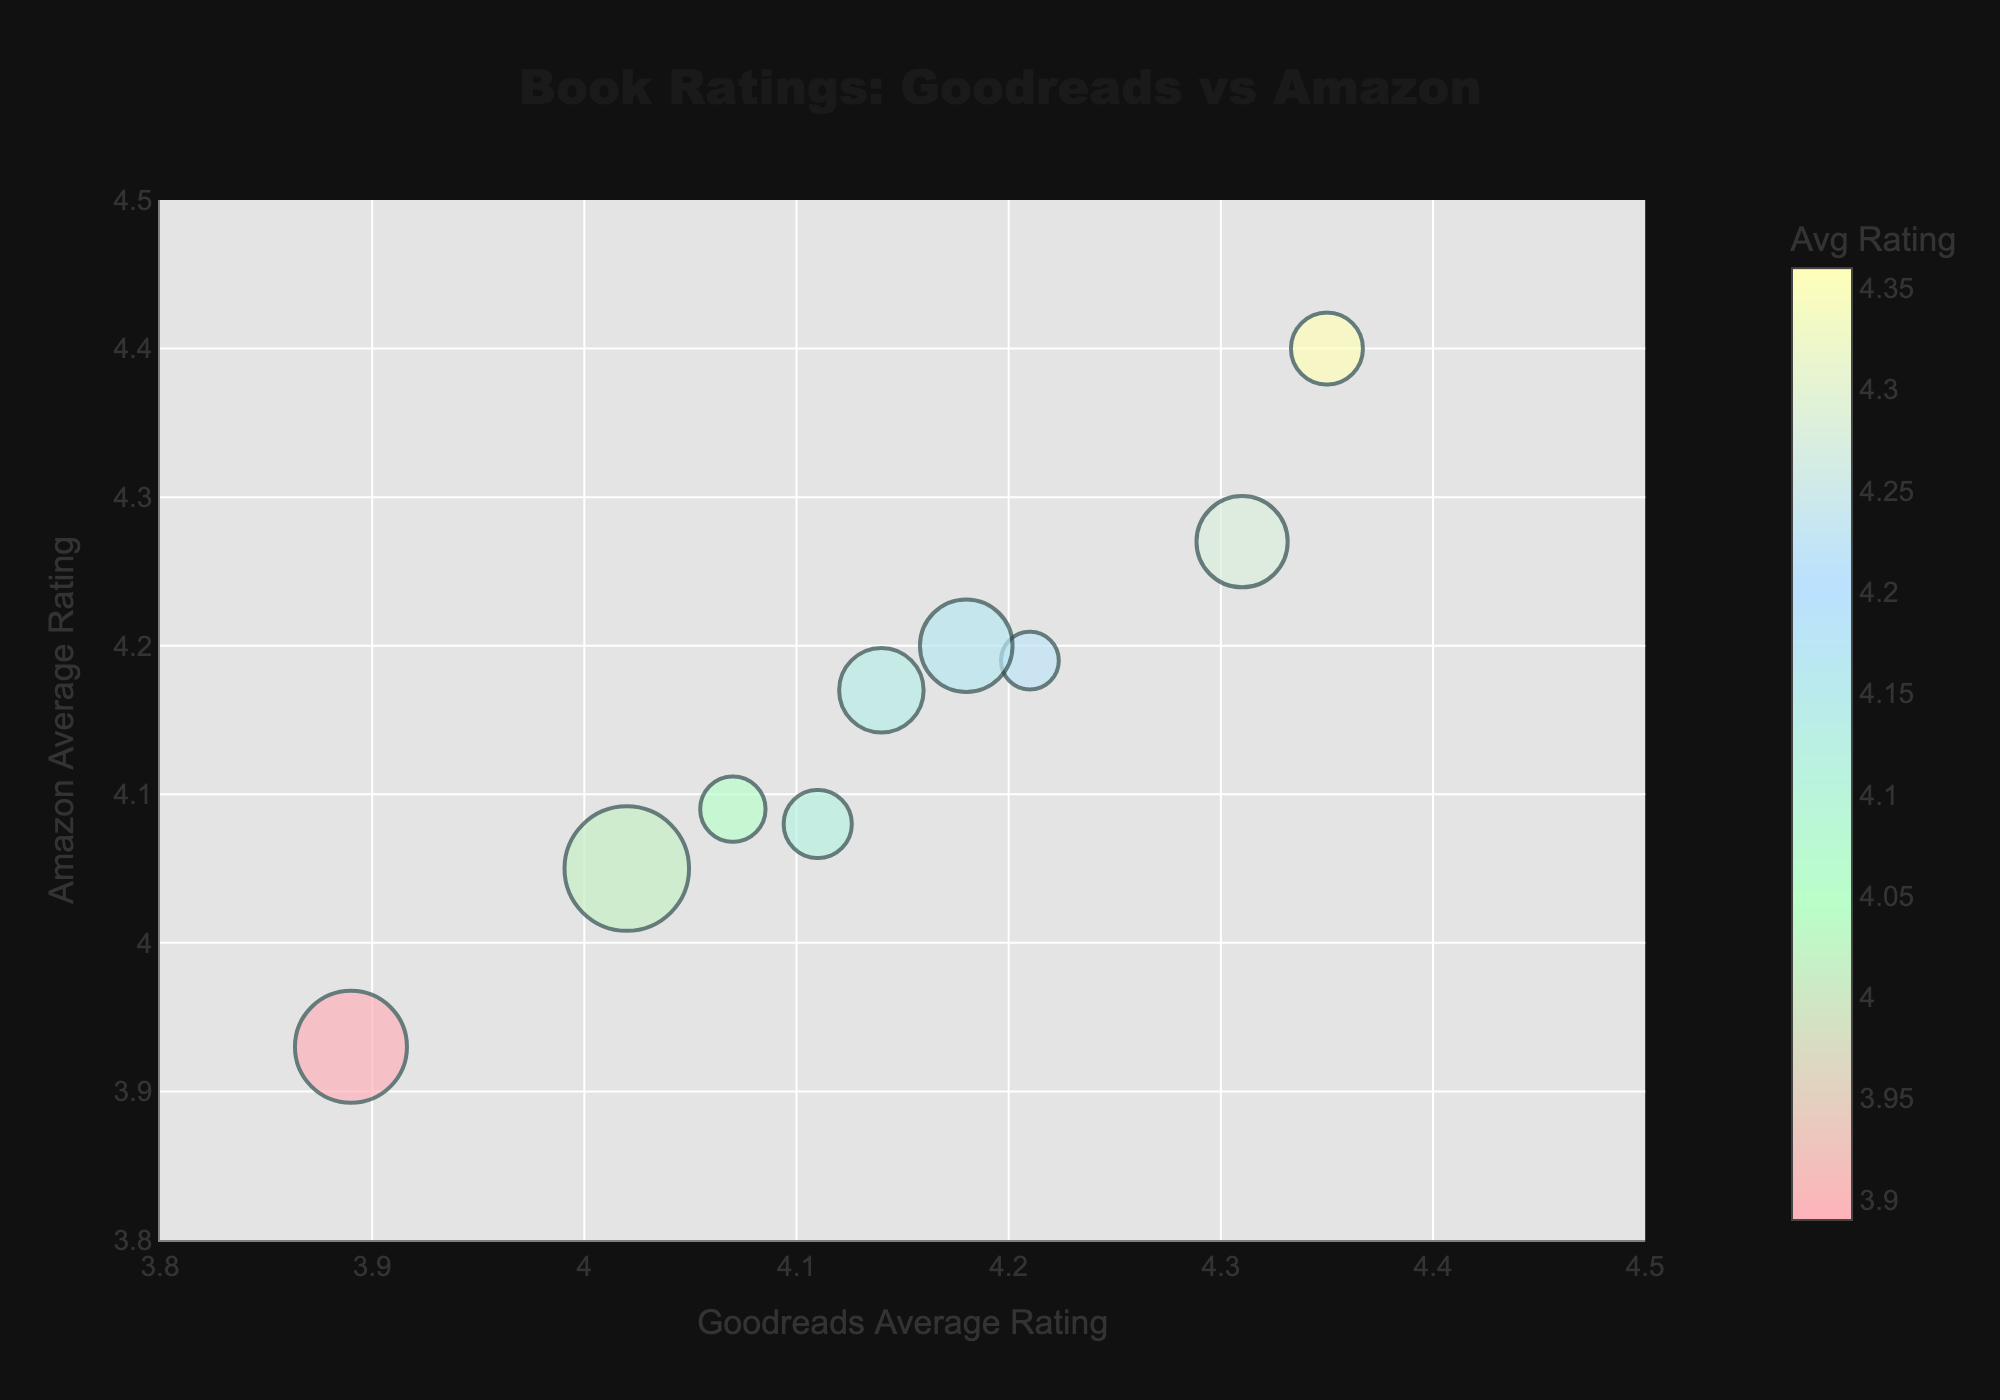What is the title of the chart? The title is usually placed at the top of the chart. In this case, it reads "Book Ratings: Goodreads vs Amazon".
Answer: Book Ratings: Goodreads vs Amazon What does the size of each bubble represent? The size of each bubble represents the number of reviews that each book received, as indicated in the hover template of the plot.
Answer: Number of reviews Which book has the highest average rating on Amazon? By comparing the vertical positions of the bubbles on the y-axis (Amazon Average Rating), "Pet" by Akwaeke Emezi has the highest position with a rating of 4.40.
Answer: Pet What is the average rating for "Mask of Shadows" on Goodreads? By locating the bubble for "Mask of Shadows" and looking at its position on the x-axis, the Goodreads average rating is 3.89.
Answer: 3.89 Among the books with a Goodreads average rating greater than 4.0, which one has the fewest reviews? Identify books with Goodreads ratings above 4.0 on the x-axis, then compare their bubble sizes. "When the Moon Was Ours" has the smallest bubble among them, indicating the fewest reviews with 654.
Answer: When the Moon Was Ours Which book has the most consistent rating across all three platforms? To determine consistency, find the book whose ratings across Goodreads, Amazon, and Barnes & Noble are closest to each other. "Pet" by Akwaeke Emezi has ratings of 4.35, 4.40, and 4.33, showing high consistency.
Answer: Pet Between "Middlesex" and "Beyond the Gender Binary", which book has a higher average rating on Goodreads? Compare the x-axis positions of the bubbles for both books. "Beyond the Gender Binary" has a Goodreads average rating of 4.31, which is higher than "Middlesex" at 4.02.
Answer: Beyond the Gender Binary What is the range of Goodreads average ratings among the books? The range is the difference between the maximum and minimum values. The highest Goodreads rating is 4.35 ("Pet") and the lowest is 3.89 ("Mask of Shadows"), so the range is 4.35 - 3.89.
Answer: 0.46 Compare "An Unkindness of Ghosts" and "I Wish You All the Best" in terms of the number of reviews. Which one has more? Check the bubble sizes: "I Wish You All the Best" has 926 reviews, whereas "An Unkindness of Ghosts" has 845 reviews. Thus, "I Wish You All the Best" has more reviews.
Answer: I Wish You All the Best 